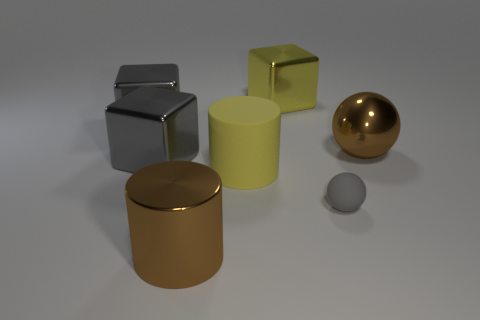Add 3 small gray matte spheres. How many objects exist? 10 Subtract all blocks. How many objects are left? 4 Subtract 0 cyan spheres. How many objects are left? 7 Subtract all small gray matte balls. Subtract all big brown metal cylinders. How many objects are left? 5 Add 5 tiny gray matte things. How many tiny gray matte things are left? 6 Add 3 green shiny cylinders. How many green shiny cylinders exist? 3 